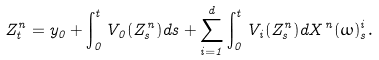Convert formula to latex. <formula><loc_0><loc_0><loc_500><loc_500>Z ^ { n } _ { t } = y _ { 0 } + \int _ { 0 } ^ { t } V _ { 0 } ( Z ^ { n } _ { s } ) d s + \sum _ { i = 1 } ^ { d } \int _ { 0 } ^ { t } V _ { i } ( Z ^ { n } _ { s } ) d X ^ { n } ( \omega ) ^ { i } _ { s } .</formula> 